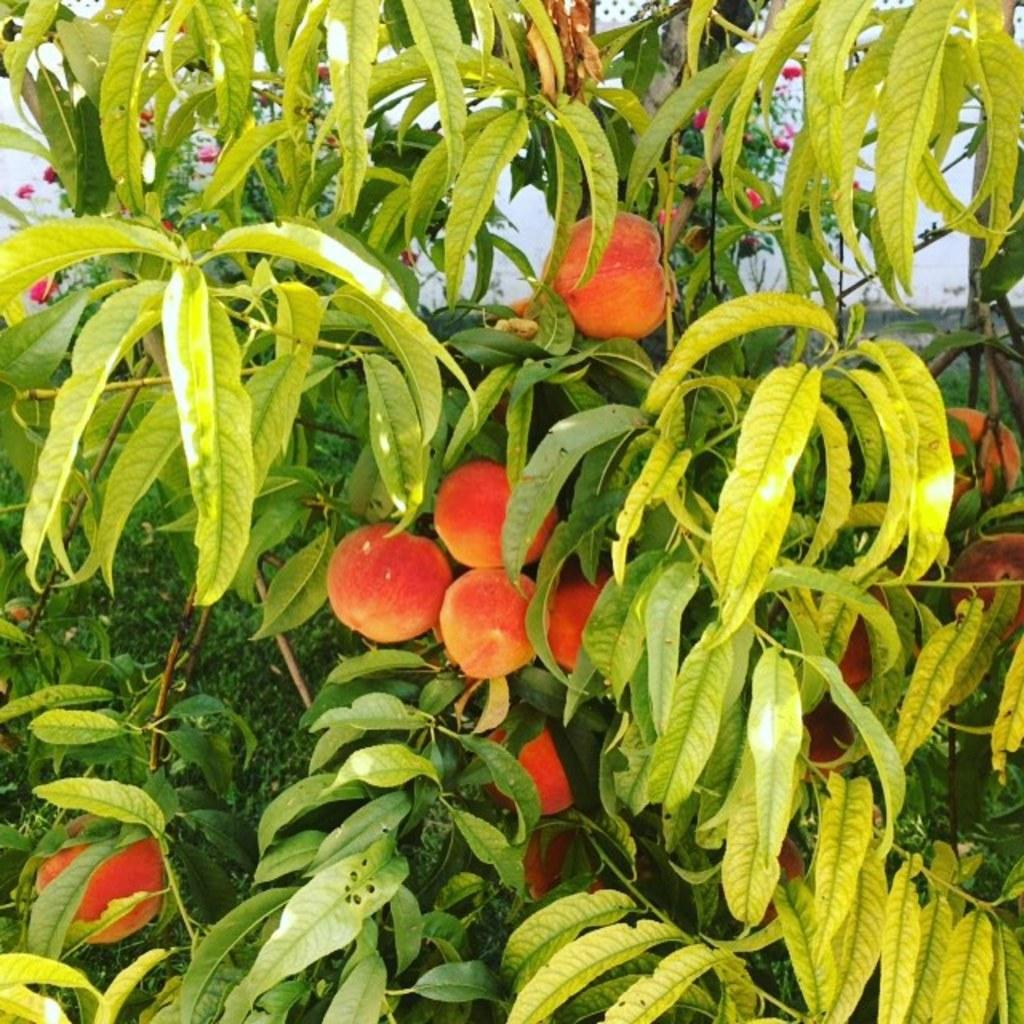What type of vegetation can be seen in the image? There are trees in the image. What else can be found among the trees in the image? There are fruits in the image. What country is the image taken in? The provided facts do not mention the country where the image was taken, so it cannot be determined from the information given. 